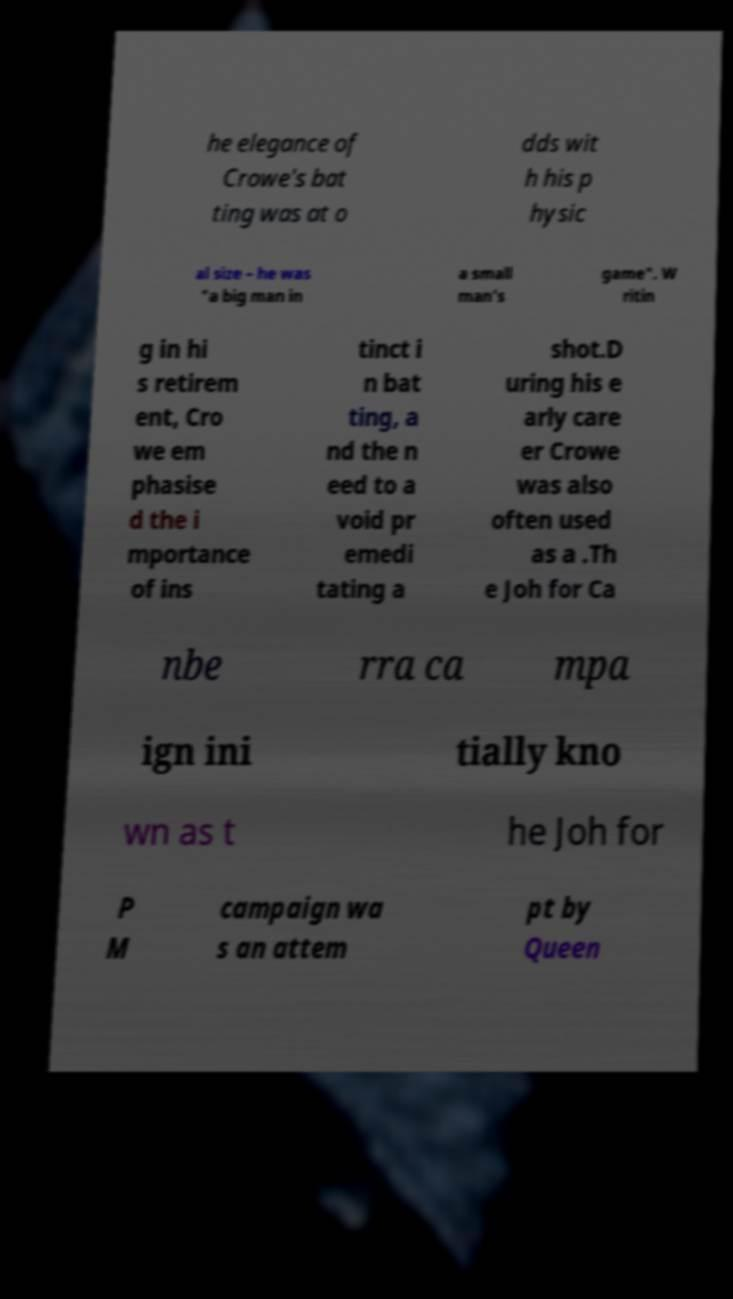Please identify and transcribe the text found in this image. he elegance of Crowe's bat ting was at o dds wit h his p hysic al size – he was "a big man in a small man's game". W ritin g in hi s retirem ent, Cro we em phasise d the i mportance of ins tinct i n bat ting, a nd the n eed to a void pr emedi tating a shot.D uring his e arly care er Crowe was also often used as a .Th e Joh for Ca nbe rra ca mpa ign ini tially kno wn as t he Joh for P M campaign wa s an attem pt by Queen 